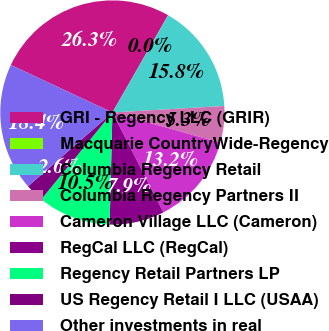<chart> <loc_0><loc_0><loc_500><loc_500><pie_chart><fcel>GRI - Regency LLC (GRIR)<fcel>Macquarie CountryWide-Regency<fcel>Columbia Regency Retail<fcel>Columbia Regency Partners II<fcel>Cameron Village LLC (Cameron)<fcel>RegCal LLC (RegCal)<fcel>Regency Retail Partners LP<fcel>US Regency Retail I LLC (USAA)<fcel>Other investments in real<nl><fcel>26.31%<fcel>0.01%<fcel>15.79%<fcel>5.27%<fcel>13.16%<fcel>7.9%<fcel>10.53%<fcel>2.64%<fcel>18.42%<nl></chart> 